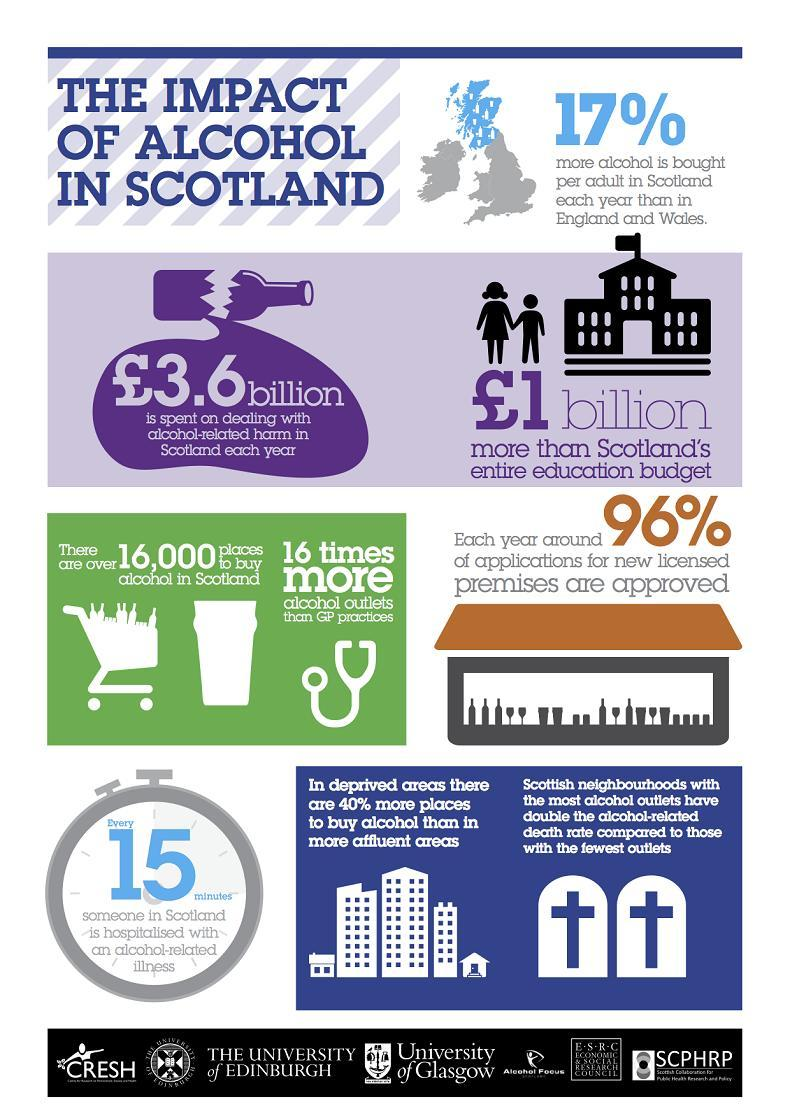How many crosses are in this infographic?
Answer the question with a short phrase. 2 How many spots are there to buy alcohol in Scotland? 16000 What is the color of the broken bottle-violet, blue, black, or green? violet How many number of buildings are in this infographic? 6 